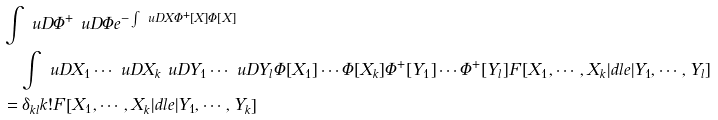Convert formula to latex. <formula><loc_0><loc_0><loc_500><loc_500>& \int \ u D \Phi ^ { + } \ u D \Phi e ^ { - \int \ u D X \Phi ^ { + } [ X ] \Phi [ X ] } \\ & \quad \int \ u D X _ { 1 } \cdots \ u D X _ { k } \ u D Y _ { 1 } \cdots \ u D Y _ { l } \Phi [ X _ { 1 } ] \cdots \Phi [ X _ { k } ] \Phi ^ { + } [ Y _ { 1 } ] \cdots \Phi ^ { + } [ Y _ { l } ] F \left [ X _ { 1 } , \cdots , X _ { k } | d l e | Y _ { 1 } , \cdots , Y _ { l } \right ] \\ & = \delta _ { k l } k ! F \left [ X _ { 1 } , \cdots , X _ { k } | d l e | Y _ { 1 } , \cdots , Y _ { k } \right ]</formula> 